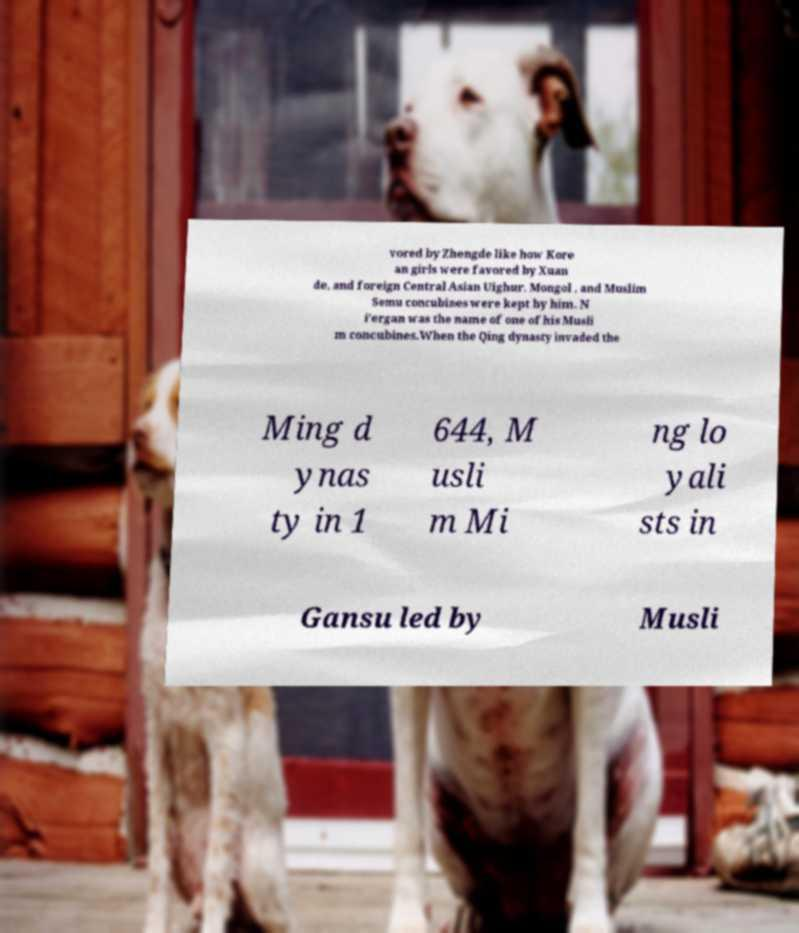Please read and relay the text visible in this image. What does it say? vored by Zhengde like how Kore an girls were favored by Xuan de, and foreign Central Asian Uighur, Mongol , and Muslim Semu concubines were kept by him. N i'ergan was the name of one of his Musli m concubines.When the Qing dynasty invaded the Ming d ynas ty in 1 644, M usli m Mi ng lo yali sts in Gansu led by Musli 